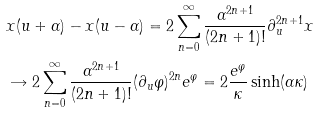<formula> <loc_0><loc_0><loc_500><loc_500>& x ( u + \alpha ) - x ( u - \alpha ) = 2 \sum _ { n = 0 } ^ { \infty } \frac { \alpha ^ { 2 n + 1 } } { ( 2 n + 1 ) ! } \partial _ { u } ^ { 2 n + 1 } x \\ & \rightarrow 2 \sum _ { n = 0 } ^ { \infty } \frac { \alpha ^ { 2 n + 1 } } { ( 2 n + 1 ) ! } ( \partial _ { u } \varphi ) ^ { 2 n } e ^ { \varphi } = 2 \frac { e ^ { \varphi } } { \kappa } \sinh ( \alpha \kappa )</formula> 